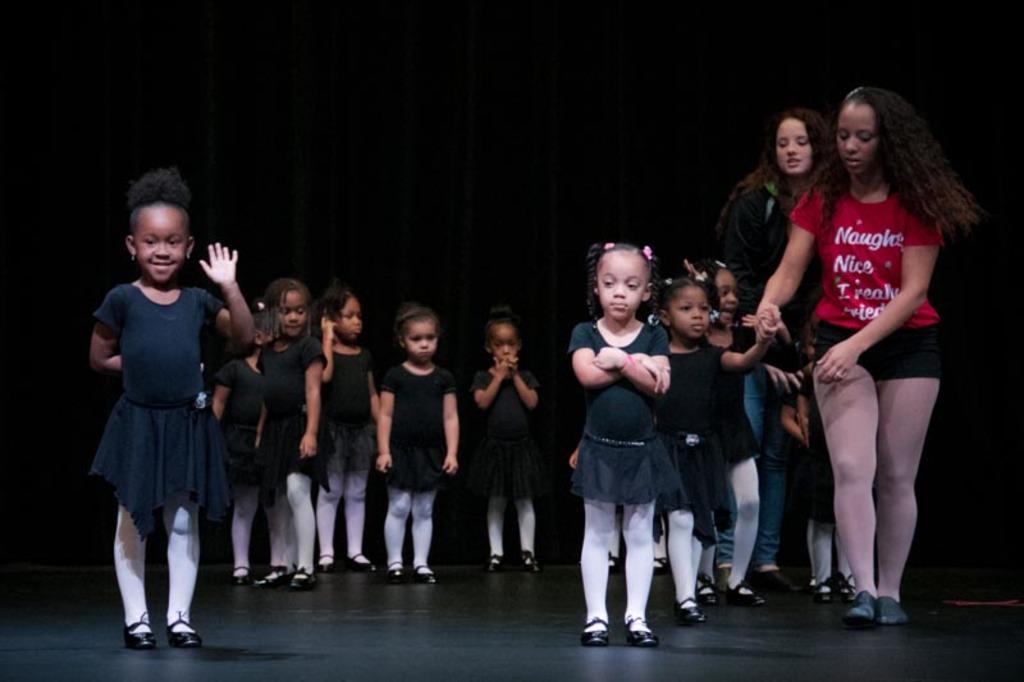In one or two sentences, can you explain what this image depicts? In this image we can see a group of children wearing black dress are standing on the floor. To the right side of the image we can see two women standing. In the background, we can see curtain. 